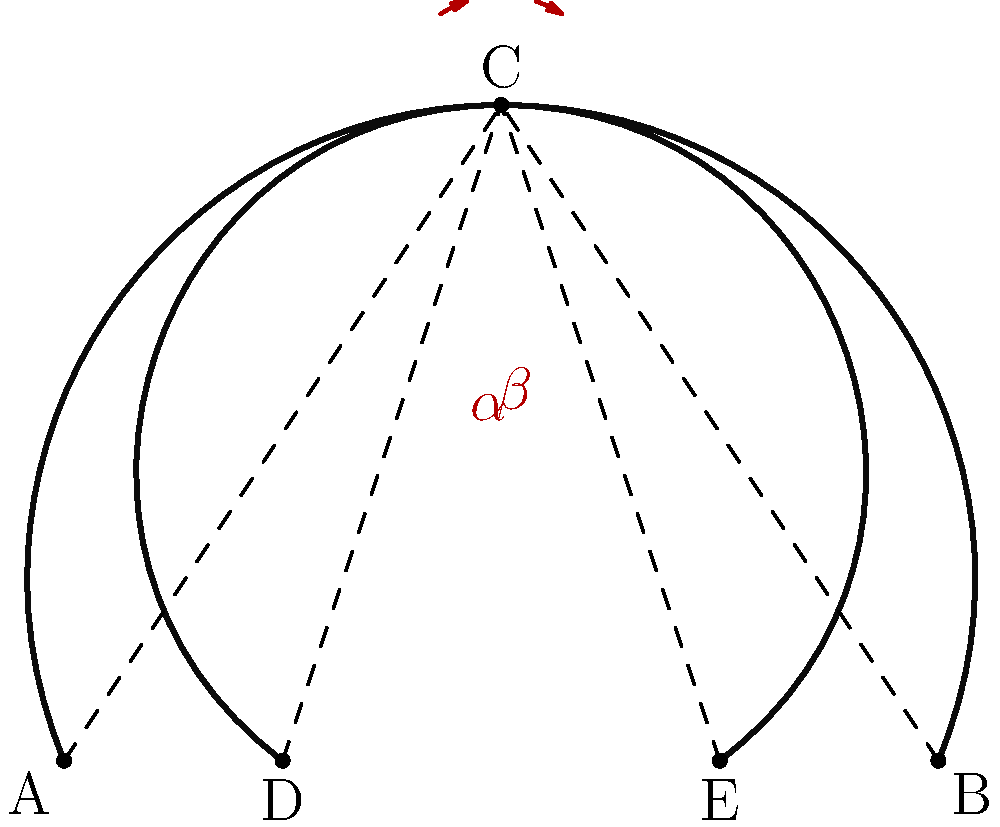In the haunting architecture of a Gothic cathedral, two intersecting arches form a mesmerizing pattern. The arches meet at point C, creating two angles, $\alpha$ and $\beta$, as shown in the diagram. If the measure of angle $\alpha$ is 45°, and the sum of angles $\alpha$ and $\beta$ is 75°, what is the measure of angle $\beta$? Express your answer in degrees. Let's approach this problem step by step, as if we were unraveling the mysteries of Gothic architecture:

1) We are given that the measure of angle $\alpha$ is 45°.

2) We are also told that the sum of angles $\alpha$ and $\beta$ is 75°.

3) We can express this information mathematically as:
   $\alpha + \beta = 75°$

4) Since we know the value of $\alpha$, we can substitute it into the equation:
   $45° + \beta = 75°$

5) To solve for $\beta$, we subtract 45° from both sides:
   $\beta = 75° - 45°$

6) Simplifying:
   $\beta = 30°$

Thus, we have determined that the measure of angle $\beta$ is 30°.
Answer: 30° 